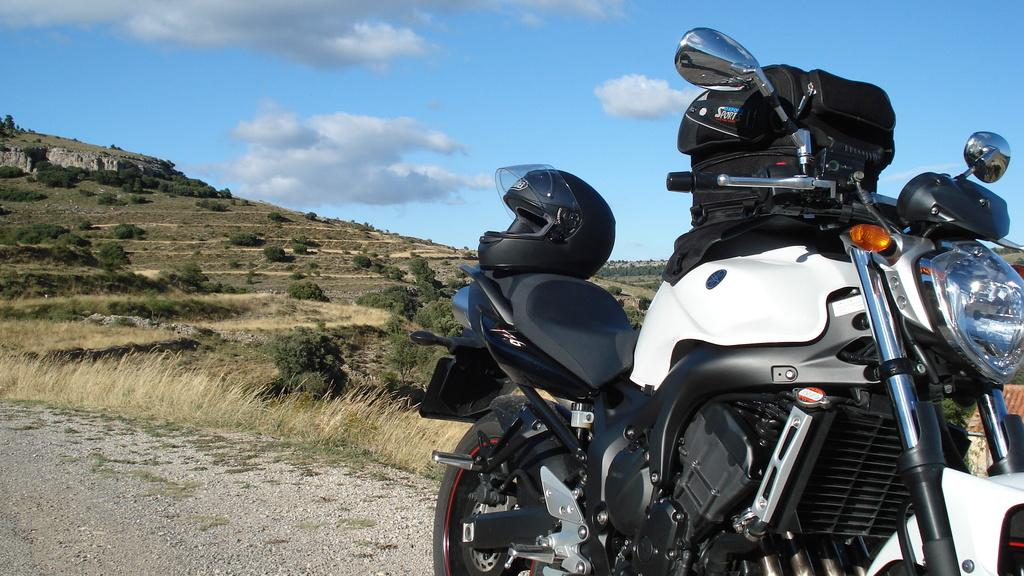What is the main object on the right side of the image? There is a bike on the right side of the image. What type of environment is depicted on the left side of the image? There is greenery on the left side of the image. Can you describe the location of the bike in relation to the greenery? The bike is on the right side of the image, while the greenery is on the left side. What type of hospital can be seen in the background of the image? There is no hospital present in the image; it features a bike and greenery. What is the reason for the mist in the image? There is no mist present in the image, so there is no reason for it. 